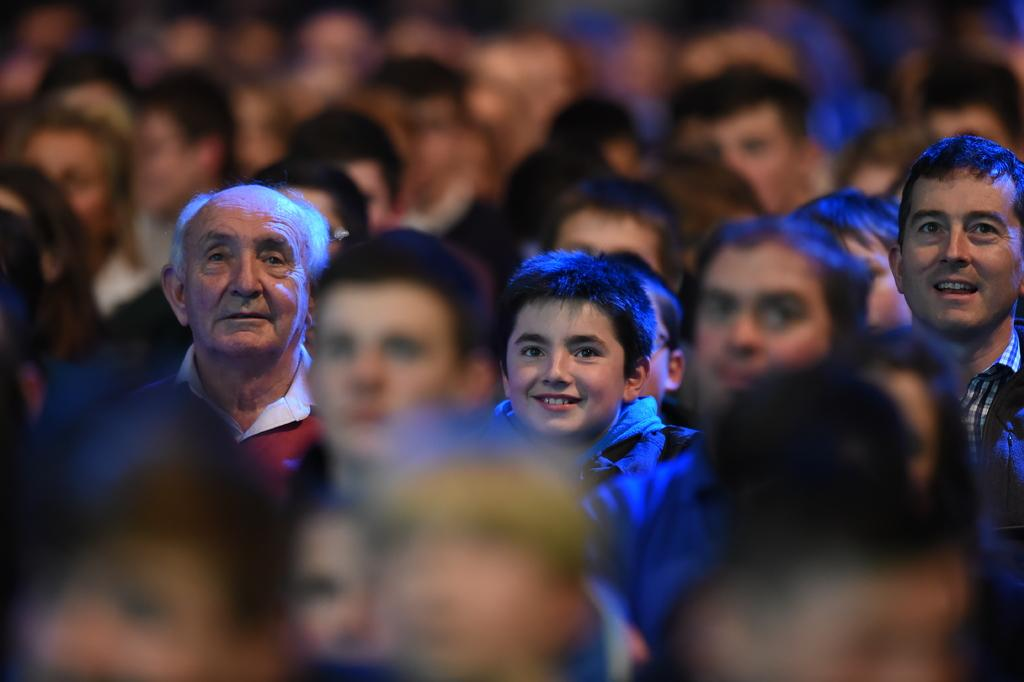How many people are in the image? The number of people in the image cannot be determined from the provided fact. What type of rake is being used by the people in the image? There is no rake present in the image, as the fact only mentions that there are people in the image. 